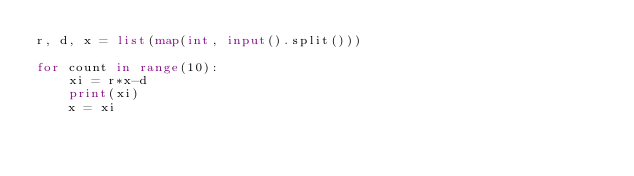<code> <loc_0><loc_0><loc_500><loc_500><_Python_>r, d, x = list(map(int, input().split()))

for count in range(10):
    xi = r*x-d
    print(xi)
    x = xi</code> 